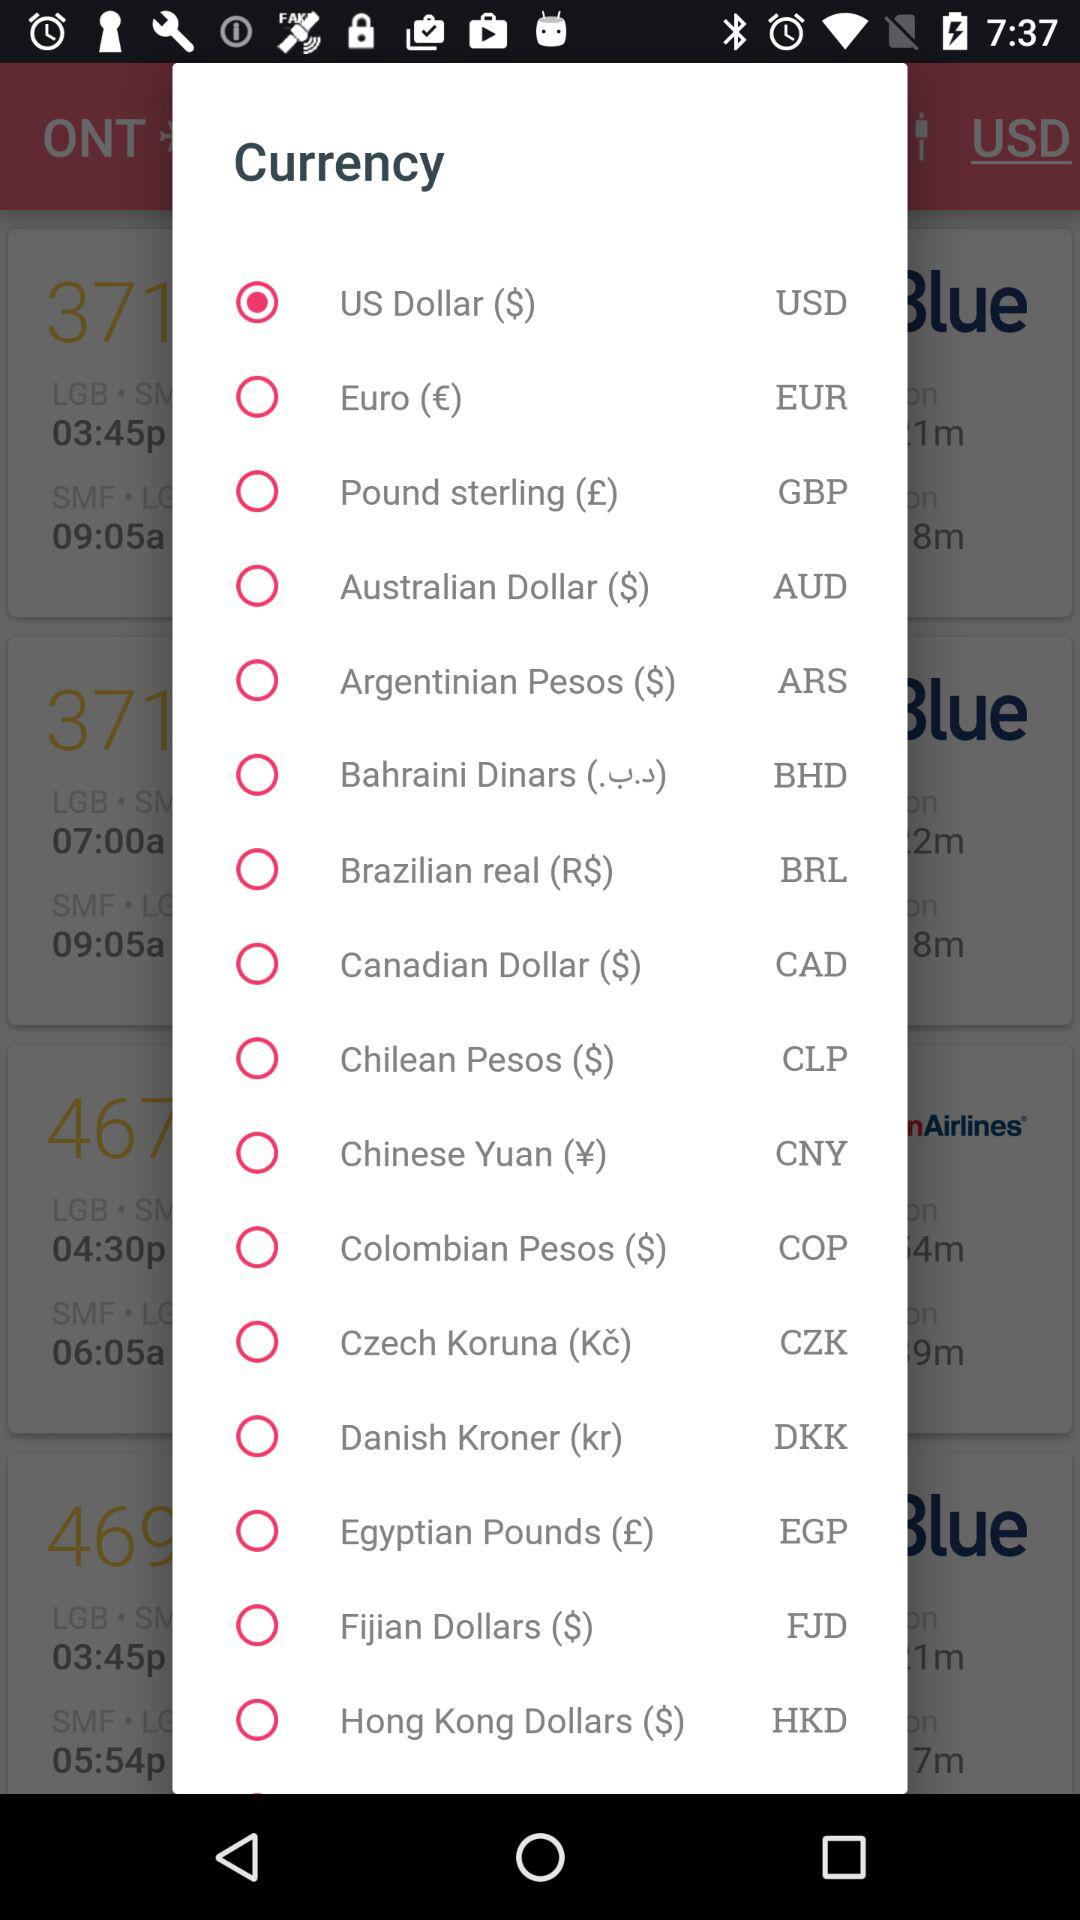How much does the flight cost?
When the provided information is insufficient, respond with <no answer>. <no answer> 